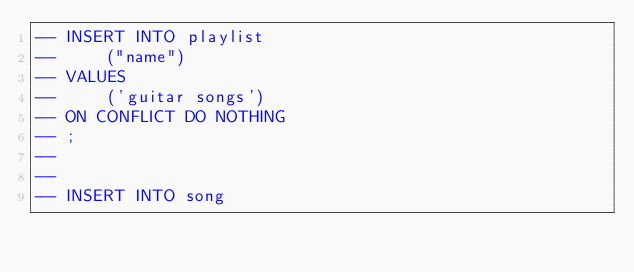Convert code to text. <code><loc_0><loc_0><loc_500><loc_500><_SQL_>-- INSERT INTO playlist
--     ("name")
-- VALUES
--     ('guitar songs')
-- ON CONFLICT DO NOTHING
-- ;
--
--
-- INSERT INTO song</code> 